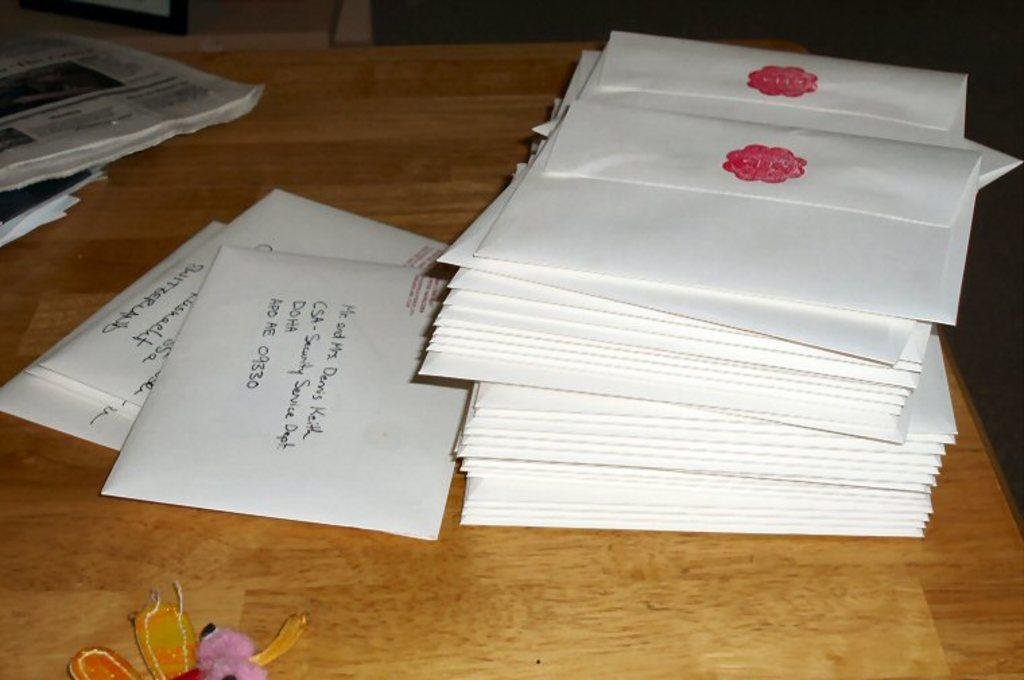<image>
Share a concise interpretation of the image provided. A stack of letters with one being addressed to Mr. and Mrs. Dennis Keith. 